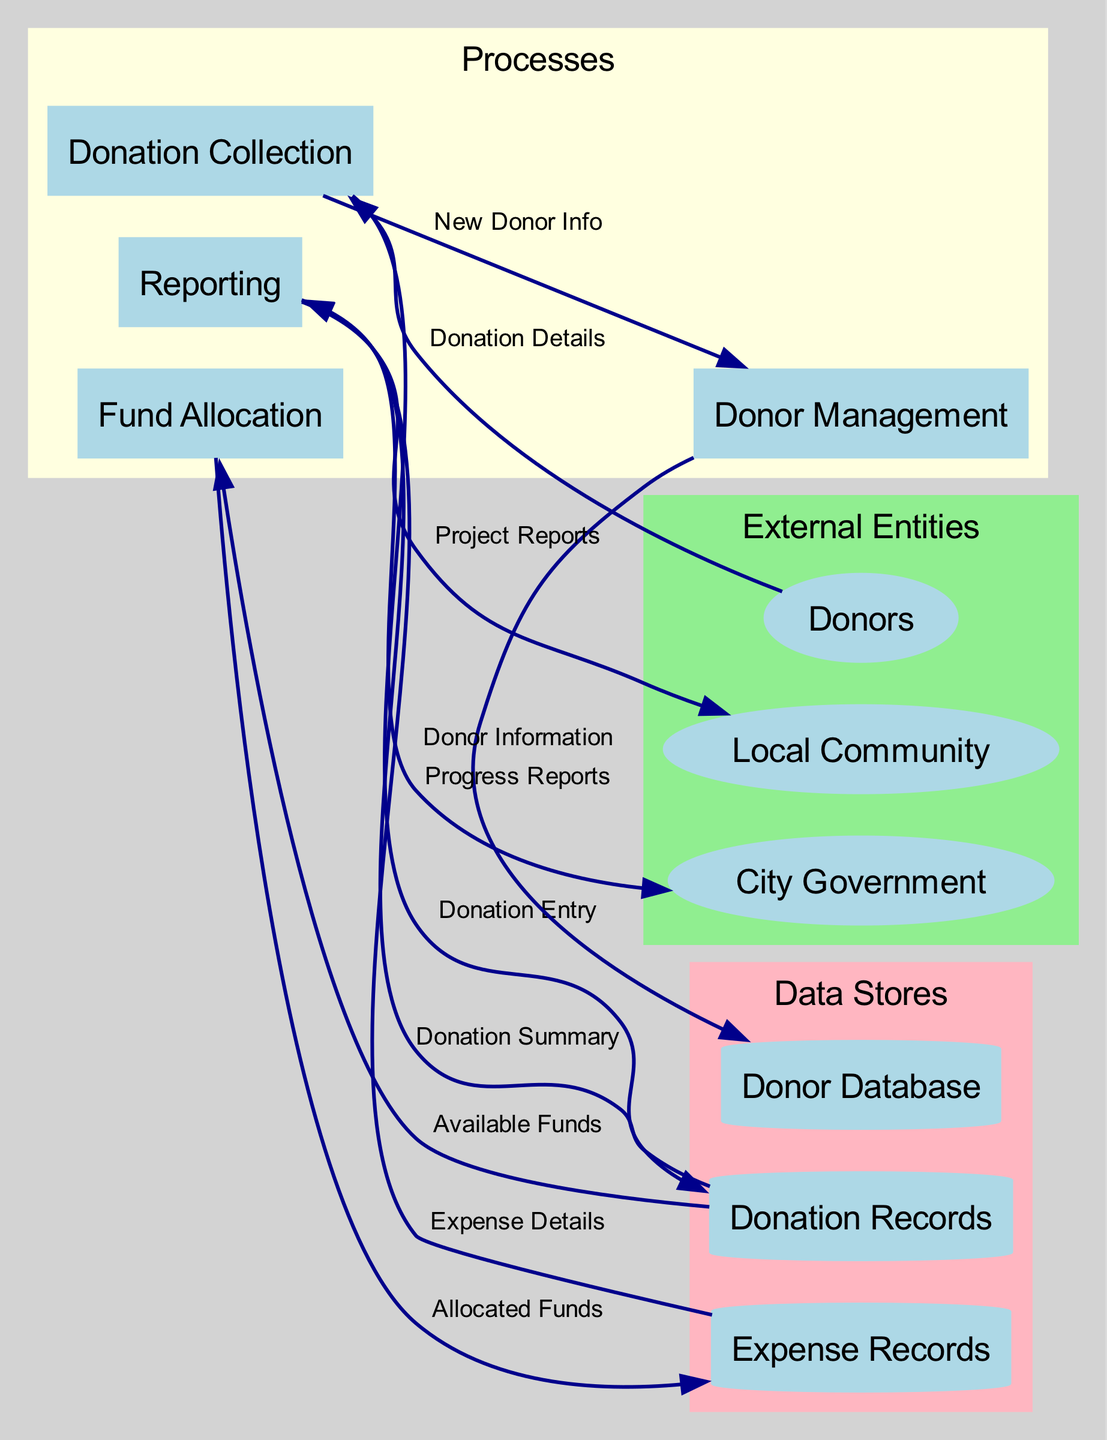What are the external entities in the diagram? The diagram lists three external entities: Donors, Local Community, and City Government.
Answer: Donors, Local Community, City Government How many processes are represented in the diagram? There are four processes depicted in the diagram: Donation Collection, Donor Management, Fund Allocation, and Reporting.
Answer: Four What data does the "Donation Collection" process receive from "Donors"? The "Donation Collection" process receives "Donation Details" from "Donors".
Answer: Donation Details Which data store receives "Donor Information" from "Donor Management"? The "Donor Database" receives "Donor Information" from "Donor Management".
Answer: Donor Database What is the flow of data from "Fund Allocation" to "Expense Records"? The "Fund Allocation" process sends "Allocated Funds" to "Expense Records".
Answer: Allocated Funds What type of reports does the "Reporting" process generate for the "Local Community"? The "Reporting" process generates "Project Reports" for the "Local Community".
Answer: Project Reports Which external entity receives "Progress Reports" from the "Reporting" process? The "City Government" receives "Progress Reports" from the "Reporting" process.
Answer: City Government What is the purpose of the "Expense Records" data store? The "Expense Records" data store logs all expenditures related to the park project.
Answer: Log of expenditures How many data flows are there from the "Donation Records" data store? There are three data flows from the "Donation Records": to Fund Allocation, to Reporting, and to Donor Management.
Answer: Three What type of data is stored in "Donation Records"? The "Donation Records" store a log of all received donations, including amounts, dates, and sources.
Answer: Log of received donations 